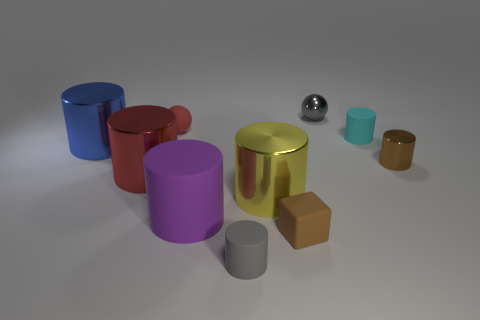What is the material of the brown object that is on the left side of the tiny cylinder that is right of the cyan rubber cylinder?
Offer a terse response. Rubber. There is a tiny object to the left of the tiny gray object in front of the ball that is to the left of the purple cylinder; what is its color?
Offer a very short reply. Red. Is the tiny shiny cylinder the same color as the small shiny sphere?
Give a very brief answer. No. What number of metal balls have the same size as the brown cube?
Provide a short and direct response. 1. Is the number of tiny gray spheres that are on the left side of the large yellow metallic cylinder greater than the number of brown metal cylinders in front of the purple thing?
Give a very brief answer. No. The small sphere that is on the right side of the matte object that is in front of the brown rubber block is what color?
Keep it short and to the point. Gray. Are the large blue object and the large red cylinder made of the same material?
Provide a succinct answer. Yes. Is there a small rubber thing that has the same shape as the small gray shiny thing?
Make the answer very short. Yes. Does the small cylinder on the left side of the rubber block have the same color as the big rubber cylinder?
Provide a succinct answer. No. Does the gray object in front of the tiny red ball have the same size as the rubber cylinder on the left side of the small gray rubber cylinder?
Make the answer very short. No. 